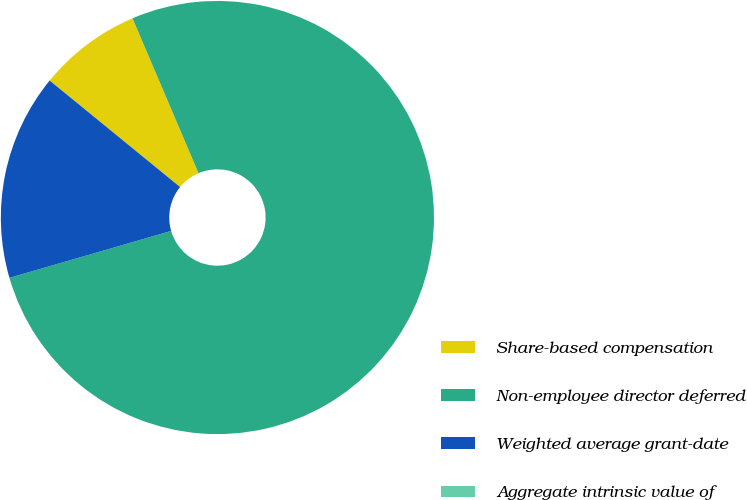<chart> <loc_0><loc_0><loc_500><loc_500><pie_chart><fcel>Share-based compensation<fcel>Non-employee director deferred<fcel>Weighted average grant-date<fcel>Aggregate intrinsic value of<nl><fcel>7.69%<fcel>76.92%<fcel>15.39%<fcel>0.0%<nl></chart> 